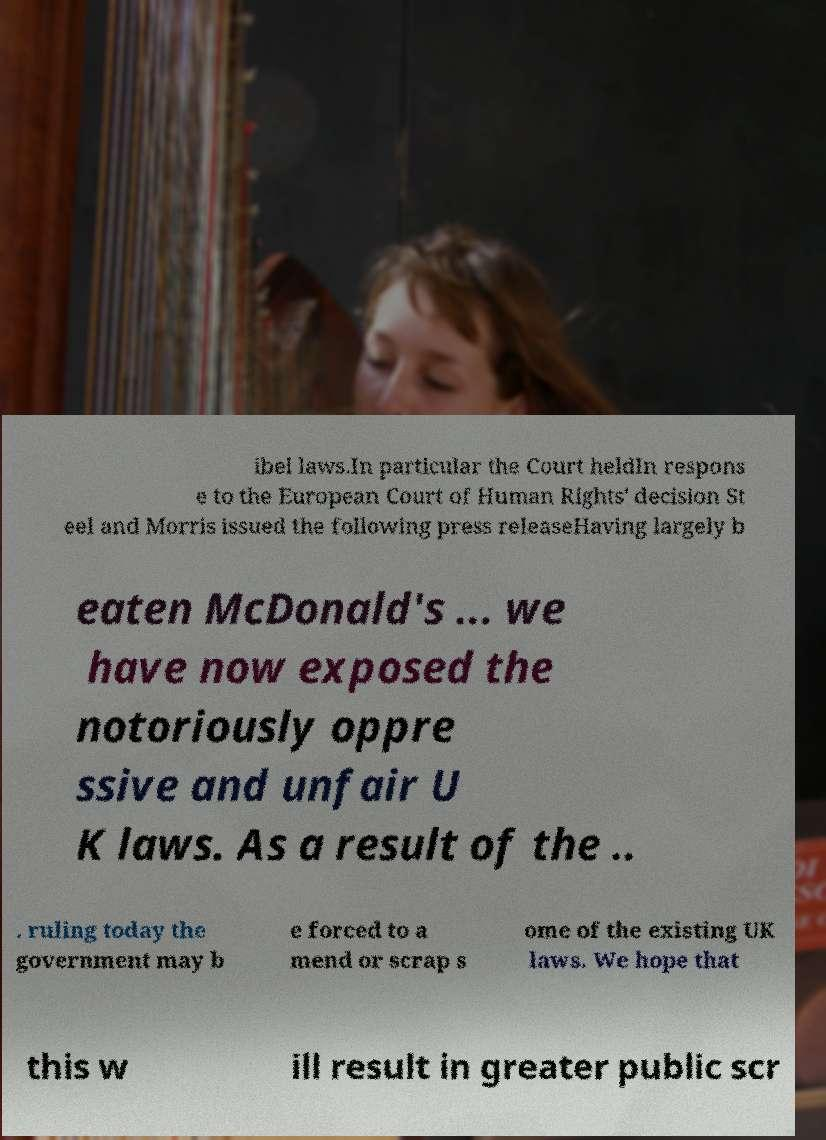I need the written content from this picture converted into text. Can you do that? ibel laws.In particular the Court heldIn respons e to the European Court of Human Rights' decision St eel and Morris issued the following press releaseHaving largely b eaten McDonald's ... we have now exposed the notoriously oppre ssive and unfair U K laws. As a result of the .. . ruling today the government may b e forced to a mend or scrap s ome of the existing UK laws. We hope that this w ill result in greater public scr 